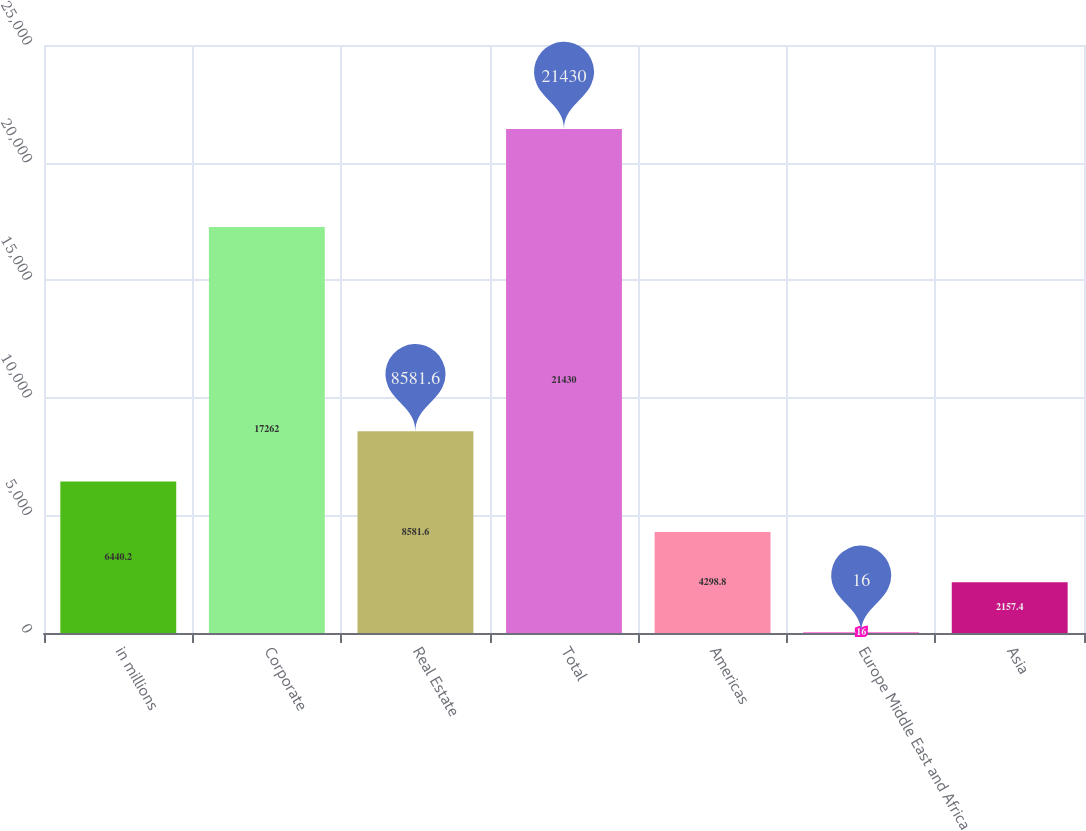Convert chart to OTSL. <chart><loc_0><loc_0><loc_500><loc_500><bar_chart><fcel>in millions<fcel>Corporate<fcel>Real Estate<fcel>Total<fcel>Americas<fcel>Europe Middle East and Africa<fcel>Asia<nl><fcel>6440.2<fcel>17262<fcel>8581.6<fcel>21430<fcel>4298.8<fcel>16<fcel>2157.4<nl></chart> 